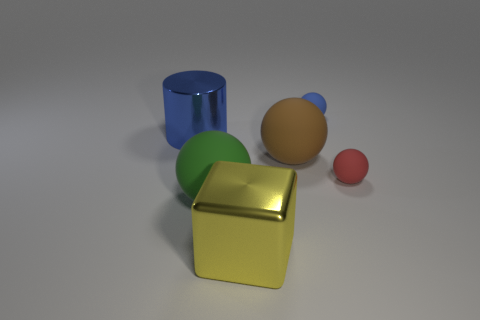Add 2 yellow shiny cubes. How many objects exist? 8 Subtract all blocks. How many objects are left? 5 Add 4 large yellow metallic things. How many large yellow metallic things are left? 5 Add 2 large green spheres. How many large green spheres exist? 3 Subtract 1 red spheres. How many objects are left? 5 Subtract all small gray matte blocks. Subtract all blue spheres. How many objects are left? 5 